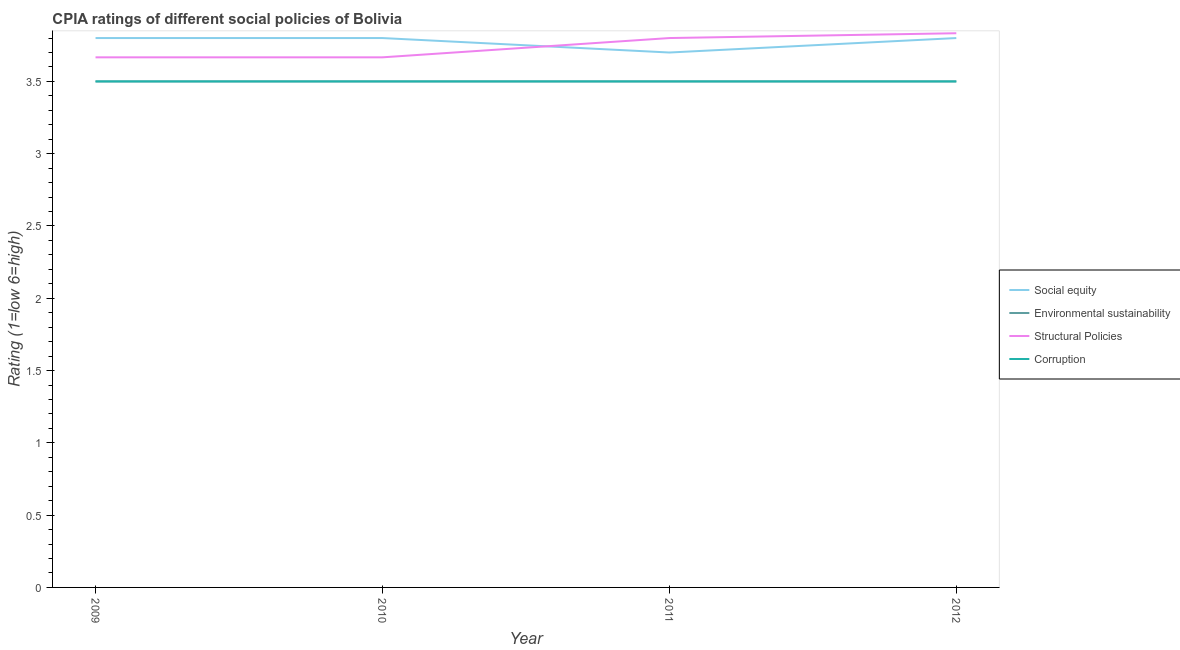Does the line corresponding to cpia rating of environmental sustainability intersect with the line corresponding to cpia rating of social equity?
Ensure brevity in your answer.  No. Is the number of lines equal to the number of legend labels?
Make the answer very short. Yes. Across all years, what is the minimum cpia rating of corruption?
Keep it short and to the point. 3.5. In which year was the cpia rating of corruption maximum?
Your answer should be compact. 2009. What is the total cpia rating of social equity in the graph?
Your answer should be very brief. 15.1. What is the difference between the cpia rating of environmental sustainability in 2010 and that in 2012?
Your answer should be very brief. 0. What is the average cpia rating of structural policies per year?
Provide a short and direct response. 3.74. In the year 2011, what is the difference between the cpia rating of corruption and cpia rating of social equity?
Provide a short and direct response. -0.2. What is the ratio of the cpia rating of structural policies in 2010 to that in 2011?
Keep it short and to the point. 0.96. Is the difference between the cpia rating of social equity in 2010 and 2011 greater than the difference between the cpia rating of environmental sustainability in 2010 and 2011?
Offer a very short reply. Yes. What is the difference between the highest and the second highest cpia rating of structural policies?
Make the answer very short. 0.03. What is the difference between the highest and the lowest cpia rating of structural policies?
Provide a succinct answer. 0.17. Is it the case that in every year, the sum of the cpia rating of social equity and cpia rating of environmental sustainability is greater than the cpia rating of structural policies?
Keep it short and to the point. Yes. Does the cpia rating of environmental sustainability monotonically increase over the years?
Ensure brevity in your answer.  No. Is the cpia rating of social equity strictly greater than the cpia rating of corruption over the years?
Your answer should be very brief. Yes. Is the cpia rating of environmental sustainability strictly less than the cpia rating of structural policies over the years?
Your answer should be compact. Yes. Are the values on the major ticks of Y-axis written in scientific E-notation?
Offer a very short reply. No. Does the graph contain any zero values?
Your answer should be compact. No. Where does the legend appear in the graph?
Offer a terse response. Center right. How many legend labels are there?
Offer a terse response. 4. How are the legend labels stacked?
Your response must be concise. Vertical. What is the title of the graph?
Your answer should be very brief. CPIA ratings of different social policies of Bolivia. What is the label or title of the X-axis?
Provide a succinct answer. Year. What is the label or title of the Y-axis?
Keep it short and to the point. Rating (1=low 6=high). What is the Rating (1=low 6=high) of Environmental sustainability in 2009?
Your response must be concise. 3.5. What is the Rating (1=low 6=high) in Structural Policies in 2009?
Give a very brief answer. 3.67. What is the Rating (1=low 6=high) of Social equity in 2010?
Your answer should be compact. 3.8. What is the Rating (1=low 6=high) of Environmental sustainability in 2010?
Offer a terse response. 3.5. What is the Rating (1=low 6=high) in Structural Policies in 2010?
Offer a very short reply. 3.67. What is the Rating (1=low 6=high) in Structural Policies in 2011?
Your answer should be very brief. 3.8. What is the Rating (1=low 6=high) in Environmental sustainability in 2012?
Provide a short and direct response. 3.5. What is the Rating (1=low 6=high) in Structural Policies in 2012?
Ensure brevity in your answer.  3.83. Across all years, what is the maximum Rating (1=low 6=high) in Social equity?
Offer a very short reply. 3.8. Across all years, what is the maximum Rating (1=low 6=high) in Environmental sustainability?
Give a very brief answer. 3.5. Across all years, what is the maximum Rating (1=low 6=high) of Structural Policies?
Offer a terse response. 3.83. Across all years, what is the maximum Rating (1=low 6=high) of Corruption?
Ensure brevity in your answer.  3.5. Across all years, what is the minimum Rating (1=low 6=high) of Environmental sustainability?
Your answer should be very brief. 3.5. Across all years, what is the minimum Rating (1=low 6=high) of Structural Policies?
Offer a terse response. 3.67. Across all years, what is the minimum Rating (1=low 6=high) of Corruption?
Ensure brevity in your answer.  3.5. What is the total Rating (1=low 6=high) in Environmental sustainability in the graph?
Keep it short and to the point. 14. What is the total Rating (1=low 6=high) in Structural Policies in the graph?
Offer a terse response. 14.97. What is the total Rating (1=low 6=high) in Corruption in the graph?
Your answer should be compact. 14. What is the difference between the Rating (1=low 6=high) of Environmental sustainability in 2009 and that in 2010?
Your answer should be very brief. 0. What is the difference between the Rating (1=low 6=high) of Social equity in 2009 and that in 2011?
Offer a terse response. 0.1. What is the difference between the Rating (1=low 6=high) of Structural Policies in 2009 and that in 2011?
Offer a terse response. -0.13. What is the difference between the Rating (1=low 6=high) of Structural Policies in 2009 and that in 2012?
Your answer should be compact. -0.17. What is the difference between the Rating (1=low 6=high) in Corruption in 2009 and that in 2012?
Keep it short and to the point. 0. What is the difference between the Rating (1=low 6=high) of Social equity in 2010 and that in 2011?
Offer a very short reply. 0.1. What is the difference between the Rating (1=low 6=high) of Structural Policies in 2010 and that in 2011?
Your response must be concise. -0.13. What is the difference between the Rating (1=low 6=high) of Social equity in 2010 and that in 2012?
Make the answer very short. 0. What is the difference between the Rating (1=low 6=high) in Corruption in 2010 and that in 2012?
Your response must be concise. 0. What is the difference between the Rating (1=low 6=high) in Social equity in 2011 and that in 2012?
Offer a terse response. -0.1. What is the difference between the Rating (1=low 6=high) in Structural Policies in 2011 and that in 2012?
Ensure brevity in your answer.  -0.03. What is the difference between the Rating (1=low 6=high) of Social equity in 2009 and the Rating (1=low 6=high) of Environmental sustainability in 2010?
Your answer should be compact. 0.3. What is the difference between the Rating (1=low 6=high) of Social equity in 2009 and the Rating (1=low 6=high) of Structural Policies in 2010?
Provide a succinct answer. 0.13. What is the difference between the Rating (1=low 6=high) in Environmental sustainability in 2009 and the Rating (1=low 6=high) in Structural Policies in 2010?
Provide a short and direct response. -0.17. What is the difference between the Rating (1=low 6=high) of Environmental sustainability in 2009 and the Rating (1=low 6=high) of Corruption in 2010?
Give a very brief answer. 0. What is the difference between the Rating (1=low 6=high) of Structural Policies in 2009 and the Rating (1=low 6=high) of Corruption in 2010?
Your answer should be compact. 0.17. What is the difference between the Rating (1=low 6=high) of Social equity in 2009 and the Rating (1=low 6=high) of Structural Policies in 2011?
Keep it short and to the point. 0. What is the difference between the Rating (1=low 6=high) of Environmental sustainability in 2009 and the Rating (1=low 6=high) of Structural Policies in 2011?
Ensure brevity in your answer.  -0.3. What is the difference between the Rating (1=low 6=high) in Social equity in 2009 and the Rating (1=low 6=high) in Structural Policies in 2012?
Offer a terse response. -0.03. What is the difference between the Rating (1=low 6=high) in Social equity in 2009 and the Rating (1=low 6=high) in Corruption in 2012?
Ensure brevity in your answer.  0.3. What is the difference between the Rating (1=low 6=high) in Environmental sustainability in 2009 and the Rating (1=low 6=high) in Corruption in 2012?
Provide a succinct answer. 0. What is the difference between the Rating (1=low 6=high) of Structural Policies in 2009 and the Rating (1=low 6=high) of Corruption in 2012?
Keep it short and to the point. 0.17. What is the difference between the Rating (1=low 6=high) in Social equity in 2010 and the Rating (1=low 6=high) in Environmental sustainability in 2011?
Your answer should be compact. 0.3. What is the difference between the Rating (1=low 6=high) of Social equity in 2010 and the Rating (1=low 6=high) of Structural Policies in 2011?
Your answer should be very brief. 0. What is the difference between the Rating (1=low 6=high) in Environmental sustainability in 2010 and the Rating (1=low 6=high) in Structural Policies in 2011?
Give a very brief answer. -0.3. What is the difference between the Rating (1=low 6=high) in Environmental sustainability in 2010 and the Rating (1=low 6=high) in Corruption in 2011?
Your response must be concise. 0. What is the difference between the Rating (1=low 6=high) of Social equity in 2010 and the Rating (1=low 6=high) of Structural Policies in 2012?
Offer a very short reply. -0.03. What is the difference between the Rating (1=low 6=high) of Environmental sustainability in 2010 and the Rating (1=low 6=high) of Corruption in 2012?
Make the answer very short. 0. What is the difference between the Rating (1=low 6=high) of Structural Policies in 2010 and the Rating (1=low 6=high) of Corruption in 2012?
Give a very brief answer. 0.17. What is the difference between the Rating (1=low 6=high) in Social equity in 2011 and the Rating (1=low 6=high) in Environmental sustainability in 2012?
Give a very brief answer. 0.2. What is the difference between the Rating (1=low 6=high) of Social equity in 2011 and the Rating (1=low 6=high) of Structural Policies in 2012?
Your answer should be very brief. -0.13. What is the difference between the Rating (1=low 6=high) in Structural Policies in 2011 and the Rating (1=low 6=high) in Corruption in 2012?
Your answer should be very brief. 0.3. What is the average Rating (1=low 6=high) of Social equity per year?
Ensure brevity in your answer.  3.77. What is the average Rating (1=low 6=high) of Environmental sustainability per year?
Offer a very short reply. 3.5. What is the average Rating (1=low 6=high) in Structural Policies per year?
Offer a very short reply. 3.74. What is the average Rating (1=low 6=high) of Corruption per year?
Offer a terse response. 3.5. In the year 2009, what is the difference between the Rating (1=low 6=high) of Social equity and Rating (1=low 6=high) of Environmental sustainability?
Provide a succinct answer. 0.3. In the year 2009, what is the difference between the Rating (1=low 6=high) in Social equity and Rating (1=low 6=high) in Structural Policies?
Your answer should be very brief. 0.13. In the year 2009, what is the difference between the Rating (1=low 6=high) of Structural Policies and Rating (1=low 6=high) of Corruption?
Your response must be concise. 0.17. In the year 2010, what is the difference between the Rating (1=low 6=high) in Social equity and Rating (1=low 6=high) in Environmental sustainability?
Your answer should be very brief. 0.3. In the year 2010, what is the difference between the Rating (1=low 6=high) of Social equity and Rating (1=low 6=high) of Structural Policies?
Provide a short and direct response. 0.13. In the year 2010, what is the difference between the Rating (1=low 6=high) of Social equity and Rating (1=low 6=high) of Corruption?
Give a very brief answer. 0.3. In the year 2010, what is the difference between the Rating (1=low 6=high) of Structural Policies and Rating (1=low 6=high) of Corruption?
Your answer should be compact. 0.17. In the year 2011, what is the difference between the Rating (1=low 6=high) of Social equity and Rating (1=low 6=high) of Environmental sustainability?
Give a very brief answer. 0.2. In the year 2011, what is the difference between the Rating (1=low 6=high) of Social equity and Rating (1=low 6=high) of Corruption?
Your answer should be compact. 0.2. In the year 2011, what is the difference between the Rating (1=low 6=high) in Environmental sustainability and Rating (1=low 6=high) in Structural Policies?
Make the answer very short. -0.3. In the year 2011, what is the difference between the Rating (1=low 6=high) of Environmental sustainability and Rating (1=low 6=high) of Corruption?
Offer a terse response. 0. In the year 2012, what is the difference between the Rating (1=low 6=high) of Social equity and Rating (1=low 6=high) of Structural Policies?
Your answer should be compact. -0.03. In the year 2012, what is the difference between the Rating (1=low 6=high) in Social equity and Rating (1=low 6=high) in Corruption?
Ensure brevity in your answer.  0.3. In the year 2012, what is the difference between the Rating (1=low 6=high) of Environmental sustainability and Rating (1=low 6=high) of Structural Policies?
Your answer should be very brief. -0.33. In the year 2012, what is the difference between the Rating (1=low 6=high) in Structural Policies and Rating (1=low 6=high) in Corruption?
Offer a terse response. 0.33. What is the ratio of the Rating (1=low 6=high) of Environmental sustainability in 2009 to that in 2010?
Give a very brief answer. 1. What is the ratio of the Rating (1=low 6=high) in Social equity in 2009 to that in 2011?
Offer a terse response. 1.03. What is the ratio of the Rating (1=low 6=high) of Structural Policies in 2009 to that in 2011?
Provide a short and direct response. 0.96. What is the ratio of the Rating (1=low 6=high) of Corruption in 2009 to that in 2011?
Your answer should be very brief. 1. What is the ratio of the Rating (1=low 6=high) of Environmental sustainability in 2009 to that in 2012?
Give a very brief answer. 1. What is the ratio of the Rating (1=low 6=high) in Structural Policies in 2009 to that in 2012?
Your answer should be compact. 0.96. What is the ratio of the Rating (1=low 6=high) of Social equity in 2010 to that in 2011?
Make the answer very short. 1.03. What is the ratio of the Rating (1=low 6=high) of Environmental sustainability in 2010 to that in 2011?
Your answer should be very brief. 1. What is the ratio of the Rating (1=low 6=high) in Structural Policies in 2010 to that in 2011?
Keep it short and to the point. 0.96. What is the ratio of the Rating (1=low 6=high) of Social equity in 2010 to that in 2012?
Your answer should be compact. 1. What is the ratio of the Rating (1=low 6=high) of Structural Policies in 2010 to that in 2012?
Provide a short and direct response. 0.96. What is the ratio of the Rating (1=low 6=high) of Social equity in 2011 to that in 2012?
Make the answer very short. 0.97. What is the ratio of the Rating (1=low 6=high) of Environmental sustainability in 2011 to that in 2012?
Your answer should be compact. 1. What is the ratio of the Rating (1=low 6=high) of Structural Policies in 2011 to that in 2012?
Your answer should be compact. 0.99. What is the ratio of the Rating (1=low 6=high) of Corruption in 2011 to that in 2012?
Your response must be concise. 1. What is the difference between the highest and the second highest Rating (1=low 6=high) in Social equity?
Your answer should be very brief. 0. What is the difference between the highest and the second highest Rating (1=low 6=high) of Environmental sustainability?
Offer a terse response. 0. What is the difference between the highest and the second highest Rating (1=low 6=high) in Corruption?
Offer a very short reply. 0. What is the difference between the highest and the lowest Rating (1=low 6=high) of Structural Policies?
Your answer should be compact. 0.17. 